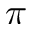<formula> <loc_0><loc_0><loc_500><loc_500>\pi</formula> 